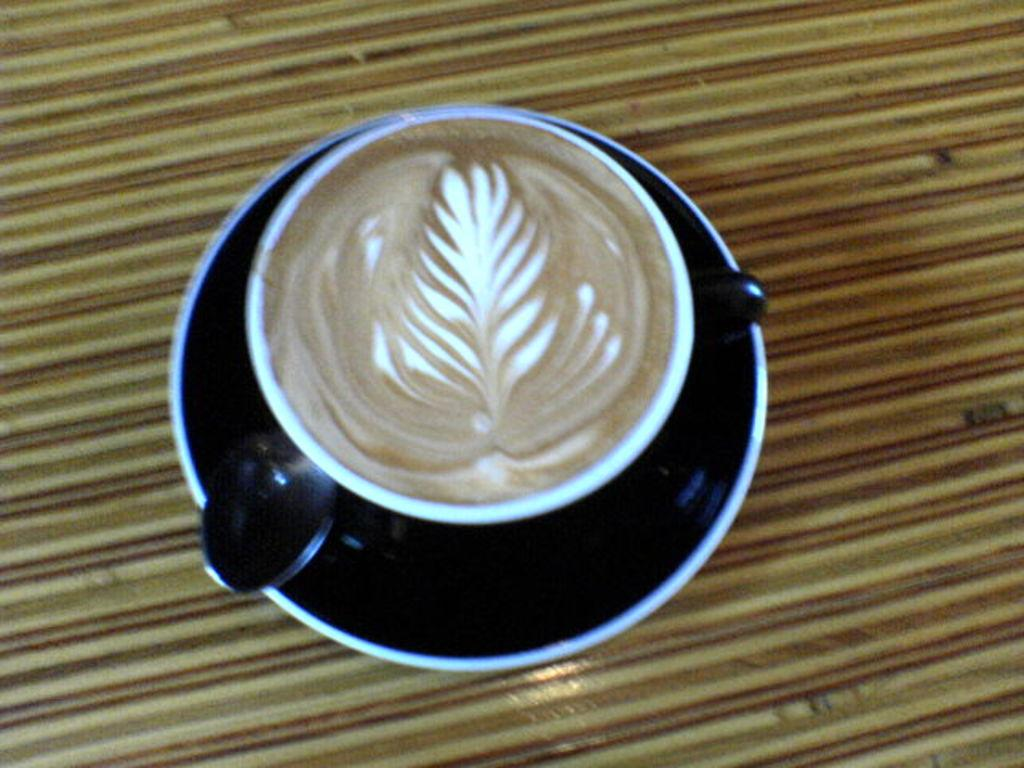What is the color of the saucer in the image? The saucer in the image is black. What is the color of the cup in the image? The cup in the image is white. What is inside the white cup? There is coffee in the white cup. What utensil is present in the image? There is a spoon in the image. What is the color of the surface in the image? The surface in the image is brown in color. Can you see a donkey enjoying pleasure in the image? No, there is no donkey or any indication of pleasure in the image. 